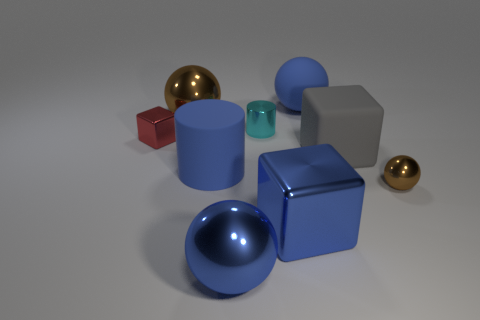Add 1 small cylinders. How many objects exist? 10 Subtract all cubes. How many objects are left? 6 Subtract 1 cyan cylinders. How many objects are left? 8 Subtract all large cyan spheres. Subtract all tiny metallic objects. How many objects are left? 6 Add 5 gray objects. How many gray objects are left? 6 Add 8 tiny brown things. How many tiny brown things exist? 9 